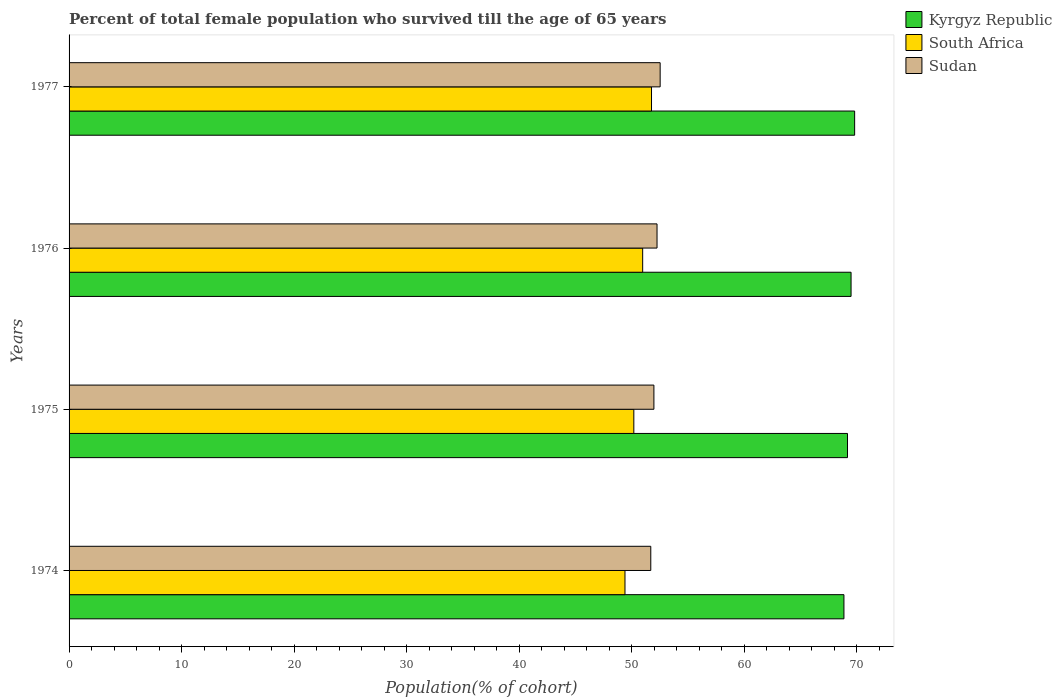How many different coloured bars are there?
Offer a terse response. 3. How many groups of bars are there?
Your answer should be very brief. 4. Are the number of bars per tick equal to the number of legend labels?
Offer a terse response. Yes. Are the number of bars on each tick of the Y-axis equal?
Your answer should be very brief. Yes. What is the label of the 4th group of bars from the top?
Your response must be concise. 1974. What is the percentage of total female population who survived till the age of 65 years in Sudan in 1975?
Keep it short and to the point. 51.96. Across all years, what is the maximum percentage of total female population who survived till the age of 65 years in Kyrgyz Republic?
Offer a very short reply. 69.8. Across all years, what is the minimum percentage of total female population who survived till the age of 65 years in Kyrgyz Republic?
Offer a very short reply. 68.85. In which year was the percentage of total female population who survived till the age of 65 years in South Africa maximum?
Ensure brevity in your answer.  1977. In which year was the percentage of total female population who survived till the age of 65 years in South Africa minimum?
Give a very brief answer. 1974. What is the total percentage of total female population who survived till the age of 65 years in Sudan in the graph?
Provide a succinct answer. 208.41. What is the difference between the percentage of total female population who survived till the age of 65 years in South Africa in 1974 and that in 1977?
Keep it short and to the point. -2.36. What is the difference between the percentage of total female population who survived till the age of 65 years in Sudan in 1977 and the percentage of total female population who survived till the age of 65 years in South Africa in 1975?
Your answer should be compact. 2.34. What is the average percentage of total female population who survived till the age of 65 years in Kyrgyz Republic per year?
Offer a terse response. 69.32. In the year 1977, what is the difference between the percentage of total female population who survived till the age of 65 years in Kyrgyz Republic and percentage of total female population who survived till the age of 65 years in South Africa?
Offer a very short reply. 18.05. What is the ratio of the percentage of total female population who survived till the age of 65 years in South Africa in 1974 to that in 1976?
Offer a terse response. 0.97. Is the difference between the percentage of total female population who survived till the age of 65 years in Kyrgyz Republic in 1975 and 1977 greater than the difference between the percentage of total female population who survived till the age of 65 years in South Africa in 1975 and 1977?
Your response must be concise. Yes. What is the difference between the highest and the second highest percentage of total female population who survived till the age of 65 years in Kyrgyz Republic?
Provide a succinct answer. 0.32. What is the difference between the highest and the lowest percentage of total female population who survived till the age of 65 years in Kyrgyz Republic?
Keep it short and to the point. 0.95. In how many years, is the percentage of total female population who survived till the age of 65 years in Sudan greater than the average percentage of total female population who survived till the age of 65 years in Sudan taken over all years?
Provide a short and direct response. 2. What does the 3rd bar from the top in 1975 represents?
Give a very brief answer. Kyrgyz Republic. What does the 1st bar from the bottom in 1977 represents?
Offer a very short reply. Kyrgyz Republic. How many years are there in the graph?
Keep it short and to the point. 4. Are the values on the major ticks of X-axis written in scientific E-notation?
Provide a succinct answer. No. Does the graph contain grids?
Your response must be concise. No. Where does the legend appear in the graph?
Give a very brief answer. Top right. How many legend labels are there?
Ensure brevity in your answer.  3. How are the legend labels stacked?
Your answer should be very brief. Vertical. What is the title of the graph?
Your response must be concise. Percent of total female population who survived till the age of 65 years. What is the label or title of the X-axis?
Offer a terse response. Population(% of cohort). What is the label or title of the Y-axis?
Your answer should be very brief. Years. What is the Population(% of cohort) of Kyrgyz Republic in 1974?
Give a very brief answer. 68.85. What is the Population(% of cohort) of South Africa in 1974?
Provide a short and direct response. 49.39. What is the Population(% of cohort) in Sudan in 1974?
Your answer should be compact. 51.69. What is the Population(% of cohort) of Kyrgyz Republic in 1975?
Offer a terse response. 69.16. What is the Population(% of cohort) of South Africa in 1975?
Your answer should be very brief. 50.18. What is the Population(% of cohort) of Sudan in 1975?
Your response must be concise. 51.96. What is the Population(% of cohort) in Kyrgyz Republic in 1976?
Your answer should be compact. 69.48. What is the Population(% of cohort) of South Africa in 1976?
Give a very brief answer. 50.96. What is the Population(% of cohort) in Sudan in 1976?
Your answer should be compact. 52.24. What is the Population(% of cohort) in Kyrgyz Republic in 1977?
Offer a terse response. 69.8. What is the Population(% of cohort) of South Africa in 1977?
Offer a terse response. 51.75. What is the Population(% of cohort) of Sudan in 1977?
Your response must be concise. 52.52. Across all years, what is the maximum Population(% of cohort) of Kyrgyz Republic?
Your response must be concise. 69.8. Across all years, what is the maximum Population(% of cohort) of South Africa?
Offer a very short reply. 51.75. Across all years, what is the maximum Population(% of cohort) of Sudan?
Your answer should be compact. 52.52. Across all years, what is the minimum Population(% of cohort) in Kyrgyz Republic?
Provide a short and direct response. 68.85. Across all years, what is the minimum Population(% of cohort) of South Africa?
Keep it short and to the point. 49.39. Across all years, what is the minimum Population(% of cohort) of Sudan?
Your answer should be compact. 51.69. What is the total Population(% of cohort) in Kyrgyz Republic in the graph?
Your answer should be compact. 277.29. What is the total Population(% of cohort) in South Africa in the graph?
Keep it short and to the point. 202.29. What is the total Population(% of cohort) in Sudan in the graph?
Your answer should be very brief. 208.41. What is the difference between the Population(% of cohort) of Kyrgyz Republic in 1974 and that in 1975?
Offer a terse response. -0.32. What is the difference between the Population(% of cohort) of South Africa in 1974 and that in 1975?
Your answer should be compact. -0.79. What is the difference between the Population(% of cohort) in Sudan in 1974 and that in 1975?
Your answer should be compact. -0.28. What is the difference between the Population(% of cohort) of Kyrgyz Republic in 1974 and that in 1976?
Offer a terse response. -0.63. What is the difference between the Population(% of cohort) in South Africa in 1974 and that in 1976?
Provide a short and direct response. -1.57. What is the difference between the Population(% of cohort) of Sudan in 1974 and that in 1976?
Offer a terse response. -0.56. What is the difference between the Population(% of cohort) in Kyrgyz Republic in 1974 and that in 1977?
Keep it short and to the point. -0.95. What is the difference between the Population(% of cohort) in South Africa in 1974 and that in 1977?
Give a very brief answer. -2.36. What is the difference between the Population(% of cohort) of Sudan in 1974 and that in 1977?
Ensure brevity in your answer.  -0.83. What is the difference between the Population(% of cohort) of Kyrgyz Republic in 1975 and that in 1976?
Your answer should be compact. -0.32. What is the difference between the Population(% of cohort) of South Africa in 1975 and that in 1976?
Your response must be concise. -0.79. What is the difference between the Population(% of cohort) in Sudan in 1975 and that in 1976?
Offer a very short reply. -0.28. What is the difference between the Population(% of cohort) of Kyrgyz Republic in 1975 and that in 1977?
Ensure brevity in your answer.  -0.63. What is the difference between the Population(% of cohort) in South Africa in 1975 and that in 1977?
Give a very brief answer. -1.57. What is the difference between the Population(% of cohort) of Sudan in 1975 and that in 1977?
Your response must be concise. -0.56. What is the difference between the Population(% of cohort) in Kyrgyz Republic in 1976 and that in 1977?
Keep it short and to the point. -0.32. What is the difference between the Population(% of cohort) in South Africa in 1976 and that in 1977?
Your response must be concise. -0.79. What is the difference between the Population(% of cohort) in Sudan in 1976 and that in 1977?
Offer a very short reply. -0.28. What is the difference between the Population(% of cohort) in Kyrgyz Republic in 1974 and the Population(% of cohort) in South Africa in 1975?
Ensure brevity in your answer.  18.67. What is the difference between the Population(% of cohort) in Kyrgyz Republic in 1974 and the Population(% of cohort) in Sudan in 1975?
Offer a terse response. 16.88. What is the difference between the Population(% of cohort) of South Africa in 1974 and the Population(% of cohort) of Sudan in 1975?
Give a very brief answer. -2.57. What is the difference between the Population(% of cohort) in Kyrgyz Republic in 1974 and the Population(% of cohort) in South Africa in 1976?
Provide a succinct answer. 17.88. What is the difference between the Population(% of cohort) in Kyrgyz Republic in 1974 and the Population(% of cohort) in Sudan in 1976?
Provide a succinct answer. 16.61. What is the difference between the Population(% of cohort) of South Africa in 1974 and the Population(% of cohort) of Sudan in 1976?
Make the answer very short. -2.85. What is the difference between the Population(% of cohort) of Kyrgyz Republic in 1974 and the Population(% of cohort) of South Africa in 1977?
Offer a terse response. 17.1. What is the difference between the Population(% of cohort) in Kyrgyz Republic in 1974 and the Population(% of cohort) in Sudan in 1977?
Offer a very short reply. 16.33. What is the difference between the Population(% of cohort) of South Africa in 1974 and the Population(% of cohort) of Sudan in 1977?
Your answer should be very brief. -3.13. What is the difference between the Population(% of cohort) in Kyrgyz Republic in 1975 and the Population(% of cohort) in South Africa in 1976?
Make the answer very short. 18.2. What is the difference between the Population(% of cohort) in Kyrgyz Republic in 1975 and the Population(% of cohort) in Sudan in 1976?
Offer a terse response. 16.92. What is the difference between the Population(% of cohort) of South Africa in 1975 and the Population(% of cohort) of Sudan in 1976?
Your answer should be compact. -2.06. What is the difference between the Population(% of cohort) in Kyrgyz Republic in 1975 and the Population(% of cohort) in South Africa in 1977?
Your answer should be compact. 17.41. What is the difference between the Population(% of cohort) of Kyrgyz Republic in 1975 and the Population(% of cohort) of Sudan in 1977?
Give a very brief answer. 16.65. What is the difference between the Population(% of cohort) in South Africa in 1975 and the Population(% of cohort) in Sudan in 1977?
Give a very brief answer. -2.34. What is the difference between the Population(% of cohort) of Kyrgyz Republic in 1976 and the Population(% of cohort) of South Africa in 1977?
Make the answer very short. 17.73. What is the difference between the Population(% of cohort) in Kyrgyz Republic in 1976 and the Population(% of cohort) in Sudan in 1977?
Your response must be concise. 16.96. What is the difference between the Population(% of cohort) in South Africa in 1976 and the Population(% of cohort) in Sudan in 1977?
Offer a terse response. -1.55. What is the average Population(% of cohort) of Kyrgyz Republic per year?
Give a very brief answer. 69.32. What is the average Population(% of cohort) in South Africa per year?
Offer a terse response. 50.57. What is the average Population(% of cohort) of Sudan per year?
Offer a very short reply. 52.1. In the year 1974, what is the difference between the Population(% of cohort) of Kyrgyz Republic and Population(% of cohort) of South Africa?
Provide a succinct answer. 19.45. In the year 1974, what is the difference between the Population(% of cohort) in Kyrgyz Republic and Population(% of cohort) in Sudan?
Provide a succinct answer. 17.16. In the year 1974, what is the difference between the Population(% of cohort) of South Africa and Population(% of cohort) of Sudan?
Offer a terse response. -2.29. In the year 1975, what is the difference between the Population(% of cohort) of Kyrgyz Republic and Population(% of cohort) of South Africa?
Offer a terse response. 18.99. In the year 1975, what is the difference between the Population(% of cohort) in Kyrgyz Republic and Population(% of cohort) in Sudan?
Give a very brief answer. 17.2. In the year 1975, what is the difference between the Population(% of cohort) of South Africa and Population(% of cohort) of Sudan?
Your answer should be compact. -1.78. In the year 1976, what is the difference between the Population(% of cohort) in Kyrgyz Republic and Population(% of cohort) in South Africa?
Provide a short and direct response. 18.52. In the year 1976, what is the difference between the Population(% of cohort) of Kyrgyz Republic and Population(% of cohort) of Sudan?
Offer a terse response. 17.24. In the year 1976, what is the difference between the Population(% of cohort) of South Africa and Population(% of cohort) of Sudan?
Keep it short and to the point. -1.28. In the year 1977, what is the difference between the Population(% of cohort) in Kyrgyz Republic and Population(% of cohort) in South Africa?
Offer a very short reply. 18.05. In the year 1977, what is the difference between the Population(% of cohort) in Kyrgyz Republic and Population(% of cohort) in Sudan?
Make the answer very short. 17.28. In the year 1977, what is the difference between the Population(% of cohort) in South Africa and Population(% of cohort) in Sudan?
Make the answer very short. -0.77. What is the ratio of the Population(% of cohort) in South Africa in 1974 to that in 1975?
Provide a short and direct response. 0.98. What is the ratio of the Population(% of cohort) in Kyrgyz Republic in 1974 to that in 1976?
Provide a short and direct response. 0.99. What is the ratio of the Population(% of cohort) in South Africa in 1974 to that in 1976?
Ensure brevity in your answer.  0.97. What is the ratio of the Population(% of cohort) of Sudan in 1974 to that in 1976?
Provide a short and direct response. 0.99. What is the ratio of the Population(% of cohort) of Kyrgyz Republic in 1974 to that in 1977?
Give a very brief answer. 0.99. What is the ratio of the Population(% of cohort) in South Africa in 1974 to that in 1977?
Ensure brevity in your answer.  0.95. What is the ratio of the Population(% of cohort) in Sudan in 1974 to that in 1977?
Ensure brevity in your answer.  0.98. What is the ratio of the Population(% of cohort) of Kyrgyz Republic in 1975 to that in 1976?
Give a very brief answer. 1. What is the ratio of the Population(% of cohort) of South Africa in 1975 to that in 1976?
Offer a very short reply. 0.98. What is the ratio of the Population(% of cohort) in Kyrgyz Republic in 1975 to that in 1977?
Your response must be concise. 0.99. What is the ratio of the Population(% of cohort) of South Africa in 1975 to that in 1977?
Provide a succinct answer. 0.97. What is the ratio of the Population(% of cohort) in Sudan in 1975 to that in 1977?
Provide a short and direct response. 0.99. What is the ratio of the Population(% of cohort) in South Africa in 1976 to that in 1977?
Offer a very short reply. 0.98. What is the difference between the highest and the second highest Population(% of cohort) in Kyrgyz Republic?
Provide a short and direct response. 0.32. What is the difference between the highest and the second highest Population(% of cohort) in South Africa?
Keep it short and to the point. 0.79. What is the difference between the highest and the second highest Population(% of cohort) in Sudan?
Provide a succinct answer. 0.28. What is the difference between the highest and the lowest Population(% of cohort) in Kyrgyz Republic?
Your response must be concise. 0.95. What is the difference between the highest and the lowest Population(% of cohort) in South Africa?
Give a very brief answer. 2.36. What is the difference between the highest and the lowest Population(% of cohort) of Sudan?
Provide a short and direct response. 0.83. 